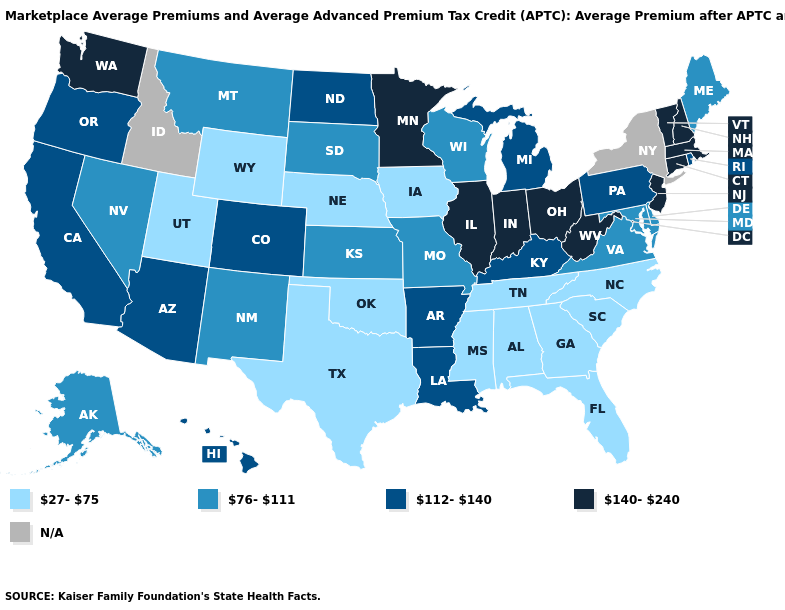What is the value of Maine?
Give a very brief answer. 76-111. Which states hav the highest value in the West?
Write a very short answer. Washington. What is the value of Maine?
Give a very brief answer. 76-111. Which states have the highest value in the USA?
Keep it brief. Connecticut, Illinois, Indiana, Massachusetts, Minnesota, New Hampshire, New Jersey, Ohio, Vermont, Washington, West Virginia. What is the value of Pennsylvania?
Short answer required. 112-140. Is the legend a continuous bar?
Give a very brief answer. No. What is the lowest value in the USA?
Be succinct. 27-75. What is the value of Alabama?
Concise answer only. 27-75. Is the legend a continuous bar?
Be succinct. No. What is the value of Arkansas?
Be succinct. 112-140. Name the states that have a value in the range 140-240?
Keep it brief. Connecticut, Illinois, Indiana, Massachusetts, Minnesota, New Hampshire, New Jersey, Ohio, Vermont, Washington, West Virginia. What is the lowest value in states that border Delaware?
Be succinct. 76-111. What is the value of Nebraska?
Keep it brief. 27-75. Is the legend a continuous bar?
Keep it brief. No. Does Utah have the lowest value in the USA?
Write a very short answer. Yes. 